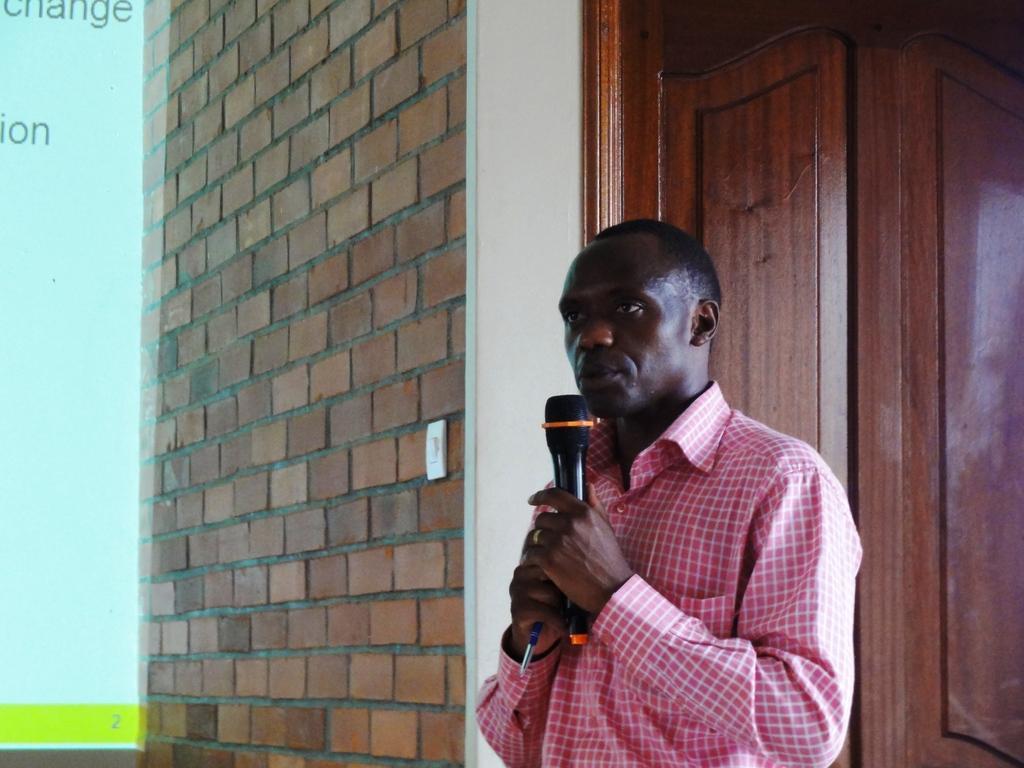Describe this image in one or two sentences. A man is speaking with a mic in his hand. 